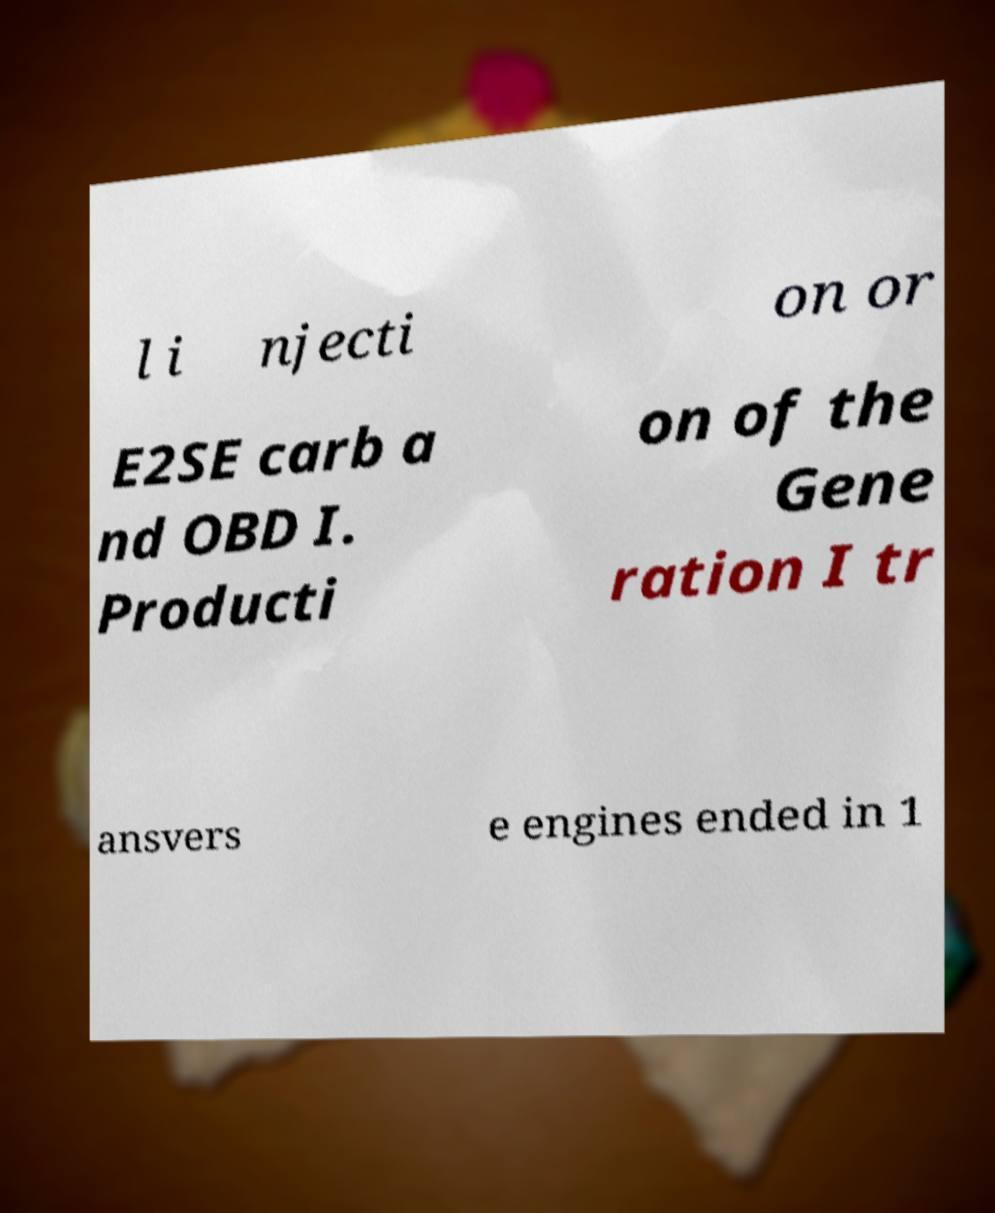Could you assist in decoding the text presented in this image and type it out clearly? l i njecti on or E2SE carb a nd OBD I. Producti on of the Gene ration I tr ansvers e engines ended in 1 